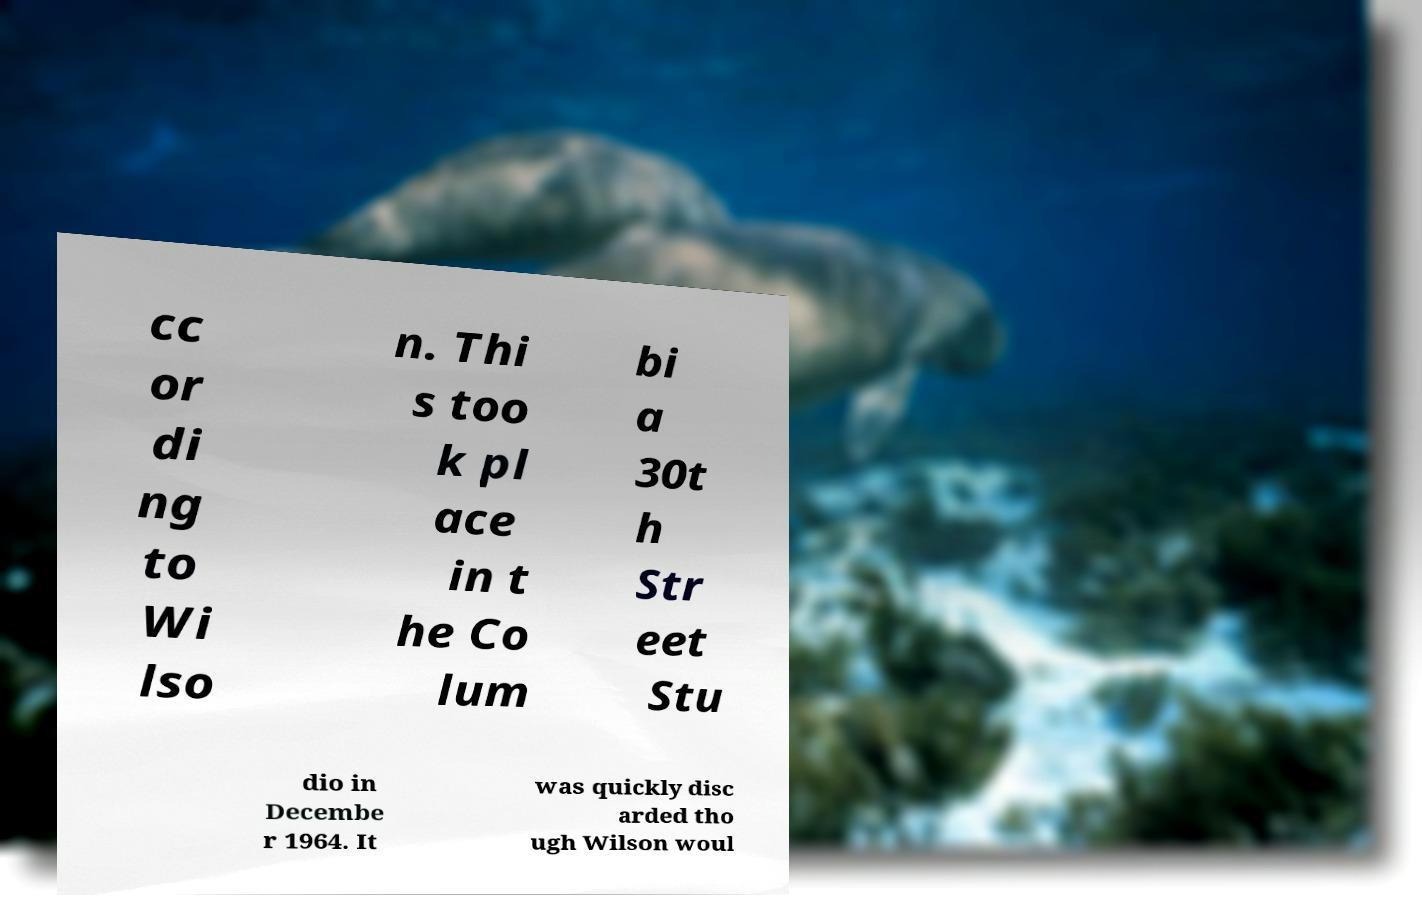Can you read and provide the text displayed in the image?This photo seems to have some interesting text. Can you extract and type it out for me? cc or di ng to Wi lso n. Thi s too k pl ace in t he Co lum bi a 30t h Str eet Stu dio in Decembe r 1964. It was quickly disc arded tho ugh Wilson woul 